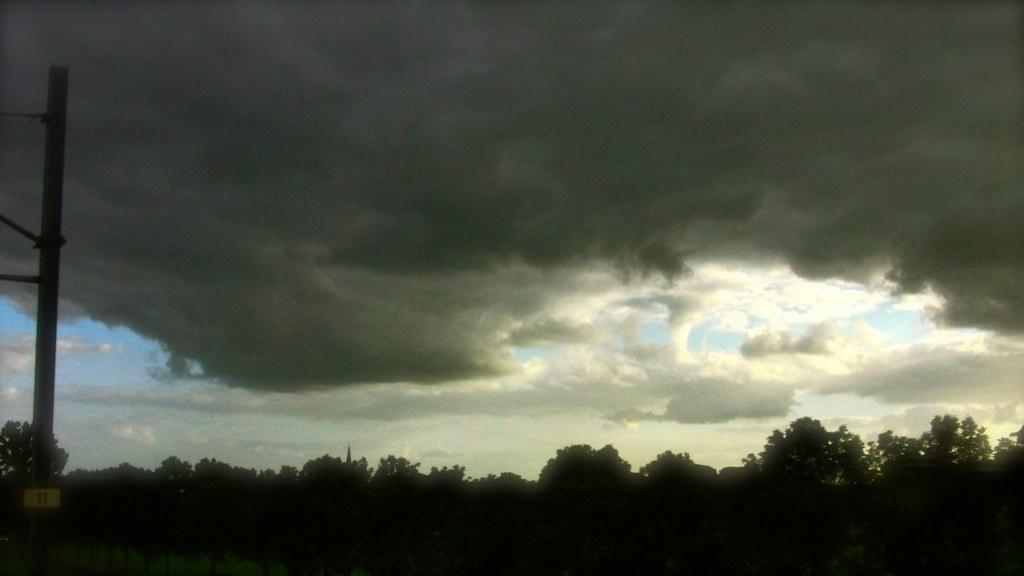What type of natural environment is depicted in the image? There are many trees in the image, suggesting a forest or wooded area. What can be seen in the sky at the top of the image? Clouds are visible in the sky at the top of the image. What object is located on the left side of the image? There is a pole on the left side of the image. What type of respect is shown by the writer in the image? There is no writer or indication of respect in the image; it primarily features trees and a pole. 